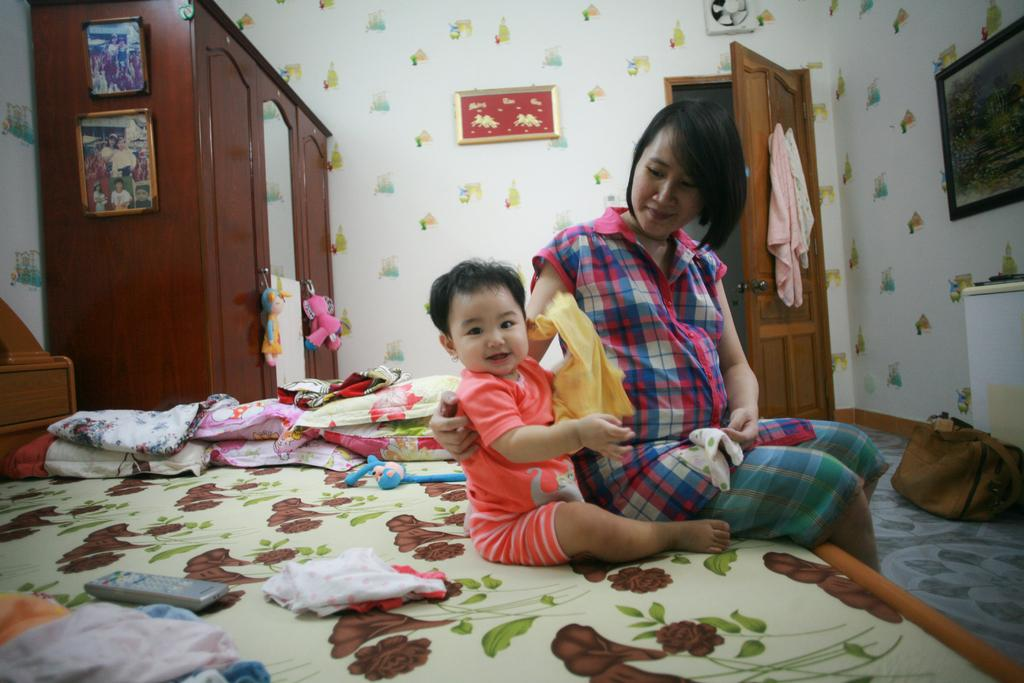What is the color of the wall in the image? The wall in the image is white. What can be seen hanging on the wall? There is a photo frame hanging on the wall. What is the purpose of the door in the image? The door in the image is likely for entering or exiting the room. What is the material of the cloth in the image? The cloth in the image could be made of various materials, but it is not specified. What is the function of the almirah in the image? The almirah is likely used for storage. What is the purpose of the mirror in the image? The mirror in the image could be used for personal grooming or to create the illusion of more space. Who are the people in the image? There is a girl and a child in the image. What are the girl and child doing in the image? The girl and child are sitting on a bed. What is the girl holding in her hand in the image? The girl is not holding anything in her hand in the image. What is the function of the remote on the bed? The remote on the bed is likely used for controlling electronic devices, such as a television or air conditioner. What is the purpose of the pillows on the bed? The pillows on the bed are likely used for comfort and support while sitting or lying down. How many pears are on the bed in the image? There are no pears present in the image. What is the length of the girl's finger in the image? The length of the girl's finger is not specified in the image. 